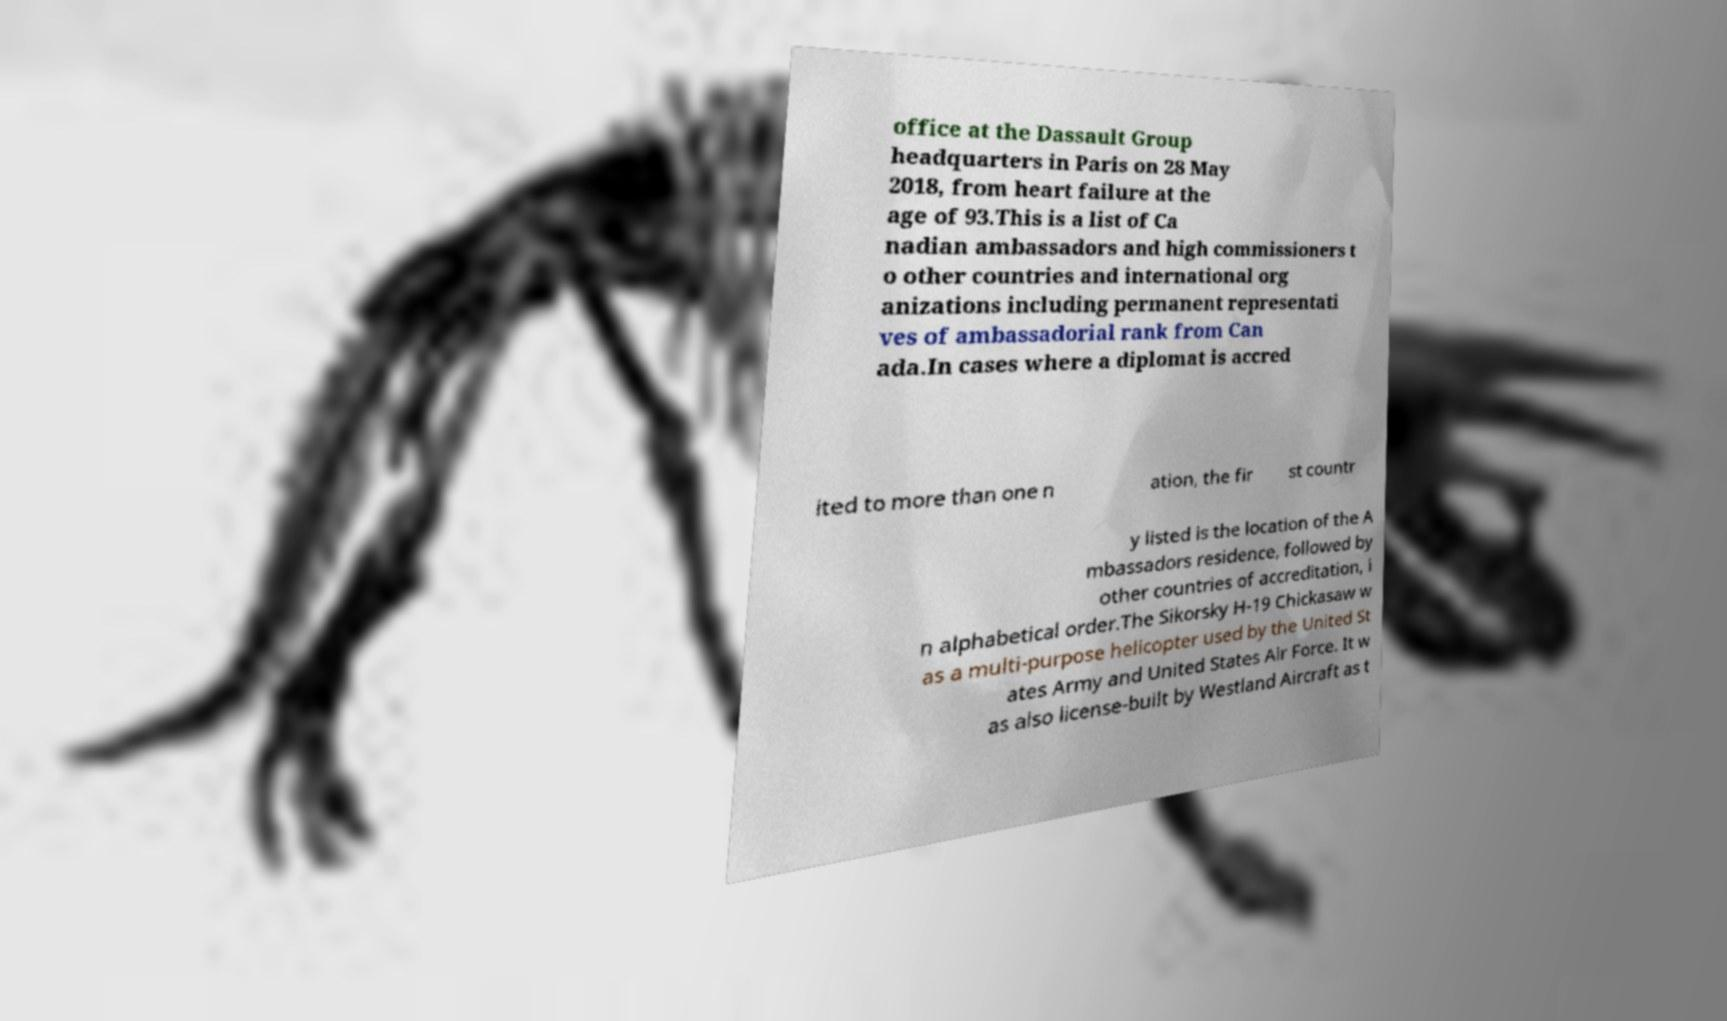I need the written content from this picture converted into text. Can you do that? office at the Dassault Group headquarters in Paris on 28 May 2018, from heart failure at the age of 93.This is a list of Ca nadian ambassadors and high commissioners t o other countries and international org anizations including permanent representati ves of ambassadorial rank from Can ada.In cases where a diplomat is accred ited to more than one n ation, the fir st countr y listed is the location of the A mbassadors residence, followed by other countries of accreditation, i n alphabetical order.The Sikorsky H-19 Chickasaw w as a multi-purpose helicopter used by the United St ates Army and United States Air Force. It w as also license-built by Westland Aircraft as t 